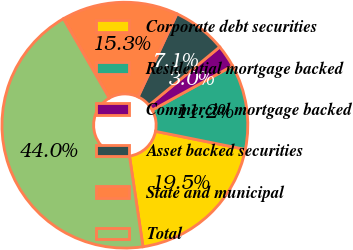<chart> <loc_0><loc_0><loc_500><loc_500><pie_chart><fcel>Corporate debt securities<fcel>Residential mortgage backed<fcel>Commercial mortgage backed<fcel>Asset backed securities<fcel>State and municipal<fcel>Total<nl><fcel>19.48%<fcel>11.18%<fcel>2.96%<fcel>7.07%<fcel>15.28%<fcel>44.03%<nl></chart> 